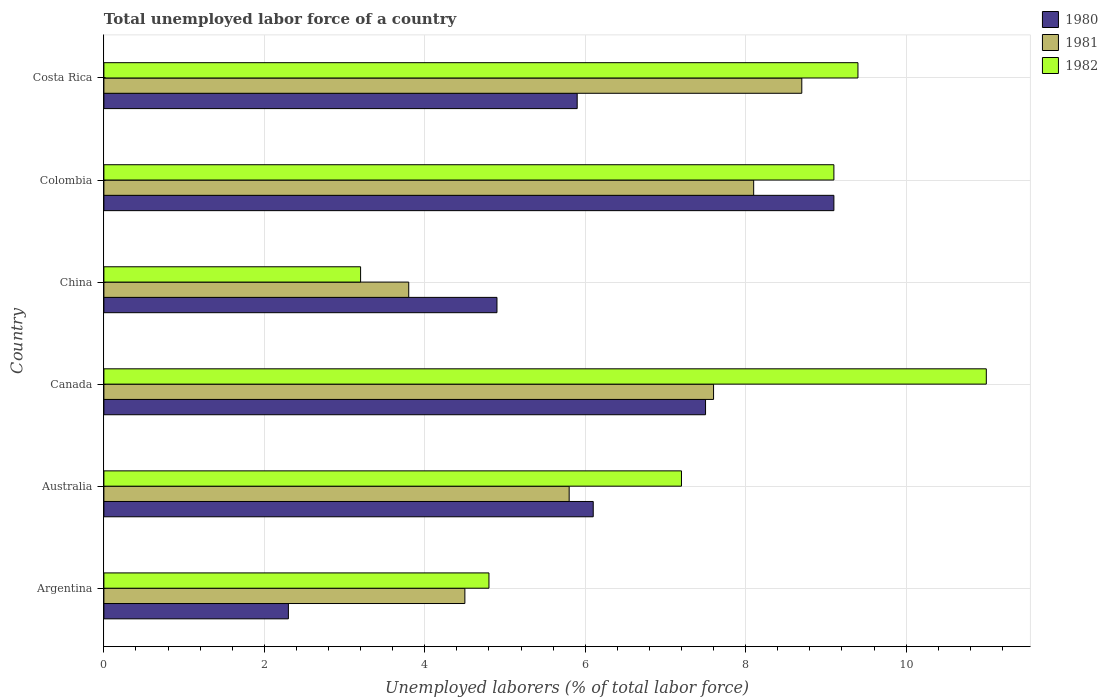How many different coloured bars are there?
Make the answer very short. 3. How many groups of bars are there?
Offer a terse response. 6. How many bars are there on the 3rd tick from the top?
Make the answer very short. 3. How many bars are there on the 4th tick from the bottom?
Offer a terse response. 3. What is the label of the 5th group of bars from the top?
Keep it short and to the point. Australia. What is the total unemployed labor force in 1982 in Costa Rica?
Keep it short and to the point. 9.4. Across all countries, what is the maximum total unemployed labor force in 1982?
Your response must be concise. 11. Across all countries, what is the minimum total unemployed labor force in 1980?
Ensure brevity in your answer.  2.3. In which country was the total unemployed labor force in 1980 minimum?
Keep it short and to the point. Argentina. What is the total total unemployed labor force in 1981 in the graph?
Your answer should be very brief. 38.5. What is the difference between the total unemployed labor force in 1982 in Argentina and that in Colombia?
Ensure brevity in your answer.  -4.3. What is the difference between the total unemployed labor force in 1981 in Costa Rica and the total unemployed labor force in 1982 in Australia?
Your response must be concise. 1.5. What is the average total unemployed labor force in 1980 per country?
Ensure brevity in your answer.  5.97. What is the difference between the total unemployed labor force in 1980 and total unemployed labor force in 1981 in Argentina?
Give a very brief answer. -2.2. What is the ratio of the total unemployed labor force in 1980 in Argentina to that in Costa Rica?
Keep it short and to the point. 0.39. Is the total unemployed labor force in 1982 in Argentina less than that in China?
Offer a very short reply. No. What is the difference between the highest and the second highest total unemployed labor force in 1982?
Keep it short and to the point. 1.6. What is the difference between the highest and the lowest total unemployed labor force in 1980?
Make the answer very short. 6.8. Is the sum of the total unemployed labor force in 1981 in Australia and Colombia greater than the maximum total unemployed labor force in 1980 across all countries?
Provide a short and direct response. Yes. What does the 3rd bar from the bottom in China represents?
Your answer should be compact. 1982. Is it the case that in every country, the sum of the total unemployed labor force in 1980 and total unemployed labor force in 1981 is greater than the total unemployed labor force in 1982?
Your answer should be very brief. Yes. How many bars are there?
Keep it short and to the point. 18. Are all the bars in the graph horizontal?
Keep it short and to the point. Yes. What is the difference between two consecutive major ticks on the X-axis?
Ensure brevity in your answer.  2. Does the graph contain any zero values?
Ensure brevity in your answer.  No. How many legend labels are there?
Offer a terse response. 3. How are the legend labels stacked?
Your response must be concise. Vertical. What is the title of the graph?
Provide a succinct answer. Total unemployed labor force of a country. Does "2006" appear as one of the legend labels in the graph?
Provide a succinct answer. No. What is the label or title of the X-axis?
Your answer should be very brief. Unemployed laborers (% of total labor force). What is the label or title of the Y-axis?
Give a very brief answer. Country. What is the Unemployed laborers (% of total labor force) in 1980 in Argentina?
Provide a succinct answer. 2.3. What is the Unemployed laborers (% of total labor force) of 1981 in Argentina?
Your answer should be compact. 4.5. What is the Unemployed laborers (% of total labor force) of 1982 in Argentina?
Keep it short and to the point. 4.8. What is the Unemployed laborers (% of total labor force) of 1980 in Australia?
Offer a very short reply. 6.1. What is the Unemployed laborers (% of total labor force) in 1981 in Australia?
Keep it short and to the point. 5.8. What is the Unemployed laborers (% of total labor force) of 1982 in Australia?
Offer a very short reply. 7.2. What is the Unemployed laborers (% of total labor force) of 1981 in Canada?
Make the answer very short. 7.6. What is the Unemployed laborers (% of total labor force) in 1980 in China?
Your answer should be compact. 4.9. What is the Unemployed laborers (% of total labor force) in 1981 in China?
Make the answer very short. 3.8. What is the Unemployed laborers (% of total labor force) in 1982 in China?
Your answer should be compact. 3.2. What is the Unemployed laborers (% of total labor force) in 1980 in Colombia?
Provide a succinct answer. 9.1. What is the Unemployed laborers (% of total labor force) of 1981 in Colombia?
Your response must be concise. 8.1. What is the Unemployed laborers (% of total labor force) of 1982 in Colombia?
Ensure brevity in your answer.  9.1. What is the Unemployed laborers (% of total labor force) of 1980 in Costa Rica?
Make the answer very short. 5.9. What is the Unemployed laborers (% of total labor force) in 1981 in Costa Rica?
Ensure brevity in your answer.  8.7. What is the Unemployed laborers (% of total labor force) of 1982 in Costa Rica?
Your response must be concise. 9.4. Across all countries, what is the maximum Unemployed laborers (% of total labor force) of 1980?
Provide a short and direct response. 9.1. Across all countries, what is the maximum Unemployed laborers (% of total labor force) of 1981?
Give a very brief answer. 8.7. Across all countries, what is the minimum Unemployed laborers (% of total labor force) in 1980?
Your response must be concise. 2.3. Across all countries, what is the minimum Unemployed laborers (% of total labor force) of 1981?
Offer a very short reply. 3.8. Across all countries, what is the minimum Unemployed laborers (% of total labor force) in 1982?
Ensure brevity in your answer.  3.2. What is the total Unemployed laborers (% of total labor force) of 1980 in the graph?
Keep it short and to the point. 35.8. What is the total Unemployed laborers (% of total labor force) of 1981 in the graph?
Ensure brevity in your answer.  38.5. What is the total Unemployed laborers (% of total labor force) of 1982 in the graph?
Your response must be concise. 44.7. What is the difference between the Unemployed laborers (% of total labor force) of 1982 in Argentina and that in Australia?
Offer a very short reply. -2.4. What is the difference between the Unemployed laborers (% of total labor force) in 1982 in Argentina and that in Canada?
Your answer should be compact. -6.2. What is the difference between the Unemployed laborers (% of total labor force) of 1980 in Argentina and that in China?
Make the answer very short. -2.6. What is the difference between the Unemployed laborers (% of total labor force) in 1982 in Argentina and that in China?
Give a very brief answer. 1.6. What is the difference between the Unemployed laborers (% of total labor force) of 1981 in Argentina and that in Colombia?
Your answer should be very brief. -3.6. What is the difference between the Unemployed laborers (% of total labor force) of 1982 in Argentina and that in Costa Rica?
Offer a very short reply. -4.6. What is the difference between the Unemployed laborers (% of total labor force) of 1981 in Australia and that in Canada?
Offer a very short reply. -1.8. What is the difference between the Unemployed laborers (% of total labor force) of 1982 in Australia and that in Canada?
Keep it short and to the point. -3.8. What is the difference between the Unemployed laborers (% of total labor force) of 1980 in Australia and that in Colombia?
Provide a succinct answer. -3. What is the difference between the Unemployed laborers (% of total labor force) of 1981 in Australia and that in Costa Rica?
Offer a very short reply. -2.9. What is the difference between the Unemployed laborers (% of total labor force) of 1982 in Australia and that in Costa Rica?
Your answer should be very brief. -2.2. What is the difference between the Unemployed laborers (% of total labor force) of 1980 in Canada and that in China?
Your response must be concise. 2.6. What is the difference between the Unemployed laborers (% of total labor force) in 1980 in Canada and that in Colombia?
Ensure brevity in your answer.  -1.6. What is the difference between the Unemployed laborers (% of total labor force) in 1981 in Canada and that in Colombia?
Your answer should be compact. -0.5. What is the difference between the Unemployed laborers (% of total labor force) of 1982 in Canada and that in Colombia?
Your answer should be very brief. 1.9. What is the difference between the Unemployed laborers (% of total labor force) of 1980 in Canada and that in Costa Rica?
Offer a terse response. 1.6. What is the difference between the Unemployed laborers (% of total labor force) in 1981 in Canada and that in Costa Rica?
Your answer should be compact. -1.1. What is the difference between the Unemployed laborers (% of total labor force) in 1982 in Canada and that in Costa Rica?
Your answer should be very brief. 1.6. What is the difference between the Unemployed laborers (% of total labor force) of 1980 in China and that in Colombia?
Your answer should be compact. -4.2. What is the difference between the Unemployed laborers (% of total labor force) in 1980 in China and that in Costa Rica?
Your response must be concise. -1. What is the difference between the Unemployed laborers (% of total labor force) in 1982 in China and that in Costa Rica?
Ensure brevity in your answer.  -6.2. What is the difference between the Unemployed laborers (% of total labor force) in 1980 in Colombia and that in Costa Rica?
Provide a succinct answer. 3.2. What is the difference between the Unemployed laborers (% of total labor force) of 1981 in Colombia and that in Costa Rica?
Provide a succinct answer. -0.6. What is the difference between the Unemployed laborers (% of total labor force) in 1981 in Argentina and the Unemployed laborers (% of total labor force) in 1982 in Canada?
Offer a very short reply. -6.5. What is the difference between the Unemployed laborers (% of total labor force) of 1980 in Argentina and the Unemployed laborers (% of total labor force) of 1981 in China?
Your response must be concise. -1.5. What is the difference between the Unemployed laborers (% of total labor force) in 1980 in Australia and the Unemployed laborers (% of total labor force) in 1981 in Canada?
Provide a short and direct response. -1.5. What is the difference between the Unemployed laborers (% of total labor force) in 1981 in Australia and the Unemployed laborers (% of total labor force) in 1982 in Canada?
Provide a short and direct response. -5.2. What is the difference between the Unemployed laborers (% of total labor force) in 1980 in Australia and the Unemployed laborers (% of total labor force) in 1982 in China?
Keep it short and to the point. 2.9. What is the difference between the Unemployed laborers (% of total labor force) of 1981 in Australia and the Unemployed laborers (% of total labor force) of 1982 in China?
Your answer should be very brief. 2.6. What is the difference between the Unemployed laborers (% of total labor force) in 1980 in Australia and the Unemployed laborers (% of total labor force) in 1981 in Colombia?
Ensure brevity in your answer.  -2. What is the difference between the Unemployed laborers (% of total labor force) of 1980 in Australia and the Unemployed laborers (% of total labor force) of 1982 in Colombia?
Provide a succinct answer. -3. What is the difference between the Unemployed laborers (% of total labor force) of 1981 in Australia and the Unemployed laborers (% of total labor force) of 1982 in Colombia?
Provide a short and direct response. -3.3. What is the difference between the Unemployed laborers (% of total labor force) of 1980 in Australia and the Unemployed laborers (% of total labor force) of 1981 in Costa Rica?
Ensure brevity in your answer.  -2.6. What is the difference between the Unemployed laborers (% of total labor force) of 1980 in Australia and the Unemployed laborers (% of total labor force) of 1982 in Costa Rica?
Keep it short and to the point. -3.3. What is the difference between the Unemployed laborers (% of total labor force) of 1981 in Canada and the Unemployed laborers (% of total labor force) of 1982 in China?
Your response must be concise. 4.4. What is the difference between the Unemployed laborers (% of total labor force) of 1980 in Canada and the Unemployed laborers (% of total labor force) of 1981 in Colombia?
Provide a succinct answer. -0.6. What is the difference between the Unemployed laborers (% of total labor force) of 1980 in Canada and the Unemployed laborers (% of total labor force) of 1982 in Colombia?
Your response must be concise. -1.6. What is the difference between the Unemployed laborers (% of total labor force) in 1981 in Canada and the Unemployed laborers (% of total labor force) in 1982 in Colombia?
Make the answer very short. -1.5. What is the difference between the Unemployed laborers (% of total labor force) in 1980 in Canada and the Unemployed laborers (% of total labor force) in 1982 in Costa Rica?
Give a very brief answer. -1.9. What is the difference between the Unemployed laborers (% of total labor force) in 1980 in China and the Unemployed laborers (% of total labor force) in 1981 in Costa Rica?
Offer a terse response. -3.8. What is the average Unemployed laborers (% of total labor force) of 1980 per country?
Keep it short and to the point. 5.97. What is the average Unemployed laborers (% of total labor force) of 1981 per country?
Make the answer very short. 6.42. What is the average Unemployed laborers (% of total labor force) of 1982 per country?
Your response must be concise. 7.45. What is the difference between the Unemployed laborers (% of total labor force) of 1980 and Unemployed laborers (% of total labor force) of 1981 in Argentina?
Your answer should be compact. -2.2. What is the difference between the Unemployed laborers (% of total labor force) of 1980 and Unemployed laborers (% of total labor force) of 1982 in Argentina?
Ensure brevity in your answer.  -2.5. What is the difference between the Unemployed laborers (% of total labor force) in 1980 and Unemployed laborers (% of total labor force) in 1982 in Australia?
Offer a terse response. -1.1. What is the difference between the Unemployed laborers (% of total labor force) in 1981 and Unemployed laborers (% of total labor force) in 1982 in Australia?
Provide a succinct answer. -1.4. What is the difference between the Unemployed laborers (% of total labor force) in 1980 and Unemployed laborers (% of total labor force) in 1981 in Canada?
Make the answer very short. -0.1. What is the difference between the Unemployed laborers (% of total labor force) in 1980 and Unemployed laborers (% of total labor force) in 1982 in Canada?
Your answer should be compact. -3.5. What is the difference between the Unemployed laborers (% of total labor force) in 1981 and Unemployed laborers (% of total labor force) in 1982 in Canada?
Give a very brief answer. -3.4. What is the difference between the Unemployed laborers (% of total labor force) in 1980 and Unemployed laborers (% of total labor force) in 1981 in China?
Make the answer very short. 1.1. What is the difference between the Unemployed laborers (% of total labor force) of 1980 and Unemployed laborers (% of total labor force) of 1982 in China?
Ensure brevity in your answer.  1.7. What is the difference between the Unemployed laborers (% of total labor force) in 1981 and Unemployed laborers (% of total labor force) in 1982 in China?
Offer a very short reply. 0.6. What is the difference between the Unemployed laborers (% of total labor force) of 1980 and Unemployed laborers (% of total labor force) of 1981 in Colombia?
Ensure brevity in your answer.  1. What is the difference between the Unemployed laborers (% of total labor force) of 1980 and Unemployed laborers (% of total labor force) of 1982 in Colombia?
Keep it short and to the point. 0. What is the difference between the Unemployed laborers (% of total labor force) in 1980 and Unemployed laborers (% of total labor force) in 1981 in Costa Rica?
Provide a short and direct response. -2.8. What is the ratio of the Unemployed laborers (% of total labor force) of 1980 in Argentina to that in Australia?
Offer a very short reply. 0.38. What is the ratio of the Unemployed laborers (% of total labor force) in 1981 in Argentina to that in Australia?
Provide a succinct answer. 0.78. What is the ratio of the Unemployed laborers (% of total labor force) in 1980 in Argentina to that in Canada?
Provide a short and direct response. 0.31. What is the ratio of the Unemployed laborers (% of total labor force) of 1981 in Argentina to that in Canada?
Make the answer very short. 0.59. What is the ratio of the Unemployed laborers (% of total labor force) in 1982 in Argentina to that in Canada?
Your answer should be very brief. 0.44. What is the ratio of the Unemployed laborers (% of total labor force) in 1980 in Argentina to that in China?
Offer a very short reply. 0.47. What is the ratio of the Unemployed laborers (% of total labor force) of 1981 in Argentina to that in China?
Your answer should be compact. 1.18. What is the ratio of the Unemployed laborers (% of total labor force) in 1980 in Argentina to that in Colombia?
Provide a succinct answer. 0.25. What is the ratio of the Unemployed laborers (% of total labor force) of 1981 in Argentina to that in Colombia?
Offer a terse response. 0.56. What is the ratio of the Unemployed laborers (% of total labor force) of 1982 in Argentina to that in Colombia?
Your response must be concise. 0.53. What is the ratio of the Unemployed laborers (% of total labor force) of 1980 in Argentina to that in Costa Rica?
Provide a short and direct response. 0.39. What is the ratio of the Unemployed laborers (% of total labor force) of 1981 in Argentina to that in Costa Rica?
Offer a terse response. 0.52. What is the ratio of the Unemployed laborers (% of total labor force) of 1982 in Argentina to that in Costa Rica?
Your answer should be very brief. 0.51. What is the ratio of the Unemployed laborers (% of total labor force) in 1980 in Australia to that in Canada?
Keep it short and to the point. 0.81. What is the ratio of the Unemployed laborers (% of total labor force) in 1981 in Australia to that in Canada?
Offer a terse response. 0.76. What is the ratio of the Unemployed laborers (% of total labor force) of 1982 in Australia to that in Canada?
Offer a terse response. 0.65. What is the ratio of the Unemployed laborers (% of total labor force) in 1980 in Australia to that in China?
Your answer should be compact. 1.24. What is the ratio of the Unemployed laborers (% of total labor force) in 1981 in Australia to that in China?
Provide a succinct answer. 1.53. What is the ratio of the Unemployed laborers (% of total labor force) of 1982 in Australia to that in China?
Ensure brevity in your answer.  2.25. What is the ratio of the Unemployed laborers (% of total labor force) of 1980 in Australia to that in Colombia?
Make the answer very short. 0.67. What is the ratio of the Unemployed laborers (% of total labor force) of 1981 in Australia to that in Colombia?
Offer a very short reply. 0.72. What is the ratio of the Unemployed laborers (% of total labor force) in 1982 in Australia to that in Colombia?
Keep it short and to the point. 0.79. What is the ratio of the Unemployed laborers (% of total labor force) of 1980 in Australia to that in Costa Rica?
Ensure brevity in your answer.  1.03. What is the ratio of the Unemployed laborers (% of total labor force) of 1982 in Australia to that in Costa Rica?
Ensure brevity in your answer.  0.77. What is the ratio of the Unemployed laborers (% of total labor force) in 1980 in Canada to that in China?
Your answer should be compact. 1.53. What is the ratio of the Unemployed laborers (% of total labor force) in 1981 in Canada to that in China?
Your response must be concise. 2. What is the ratio of the Unemployed laborers (% of total labor force) of 1982 in Canada to that in China?
Ensure brevity in your answer.  3.44. What is the ratio of the Unemployed laborers (% of total labor force) of 1980 in Canada to that in Colombia?
Give a very brief answer. 0.82. What is the ratio of the Unemployed laborers (% of total labor force) in 1981 in Canada to that in Colombia?
Keep it short and to the point. 0.94. What is the ratio of the Unemployed laborers (% of total labor force) in 1982 in Canada to that in Colombia?
Offer a very short reply. 1.21. What is the ratio of the Unemployed laborers (% of total labor force) of 1980 in Canada to that in Costa Rica?
Your answer should be very brief. 1.27. What is the ratio of the Unemployed laborers (% of total labor force) in 1981 in Canada to that in Costa Rica?
Keep it short and to the point. 0.87. What is the ratio of the Unemployed laborers (% of total labor force) of 1982 in Canada to that in Costa Rica?
Make the answer very short. 1.17. What is the ratio of the Unemployed laborers (% of total labor force) in 1980 in China to that in Colombia?
Your response must be concise. 0.54. What is the ratio of the Unemployed laborers (% of total labor force) of 1981 in China to that in Colombia?
Make the answer very short. 0.47. What is the ratio of the Unemployed laborers (% of total labor force) in 1982 in China to that in Colombia?
Your answer should be very brief. 0.35. What is the ratio of the Unemployed laborers (% of total labor force) in 1980 in China to that in Costa Rica?
Ensure brevity in your answer.  0.83. What is the ratio of the Unemployed laborers (% of total labor force) of 1981 in China to that in Costa Rica?
Keep it short and to the point. 0.44. What is the ratio of the Unemployed laborers (% of total labor force) of 1982 in China to that in Costa Rica?
Keep it short and to the point. 0.34. What is the ratio of the Unemployed laborers (% of total labor force) of 1980 in Colombia to that in Costa Rica?
Give a very brief answer. 1.54. What is the ratio of the Unemployed laborers (% of total labor force) in 1982 in Colombia to that in Costa Rica?
Ensure brevity in your answer.  0.97. What is the difference between the highest and the second highest Unemployed laborers (% of total labor force) of 1980?
Give a very brief answer. 1.6. What is the difference between the highest and the second highest Unemployed laborers (% of total labor force) of 1982?
Offer a terse response. 1.6. 